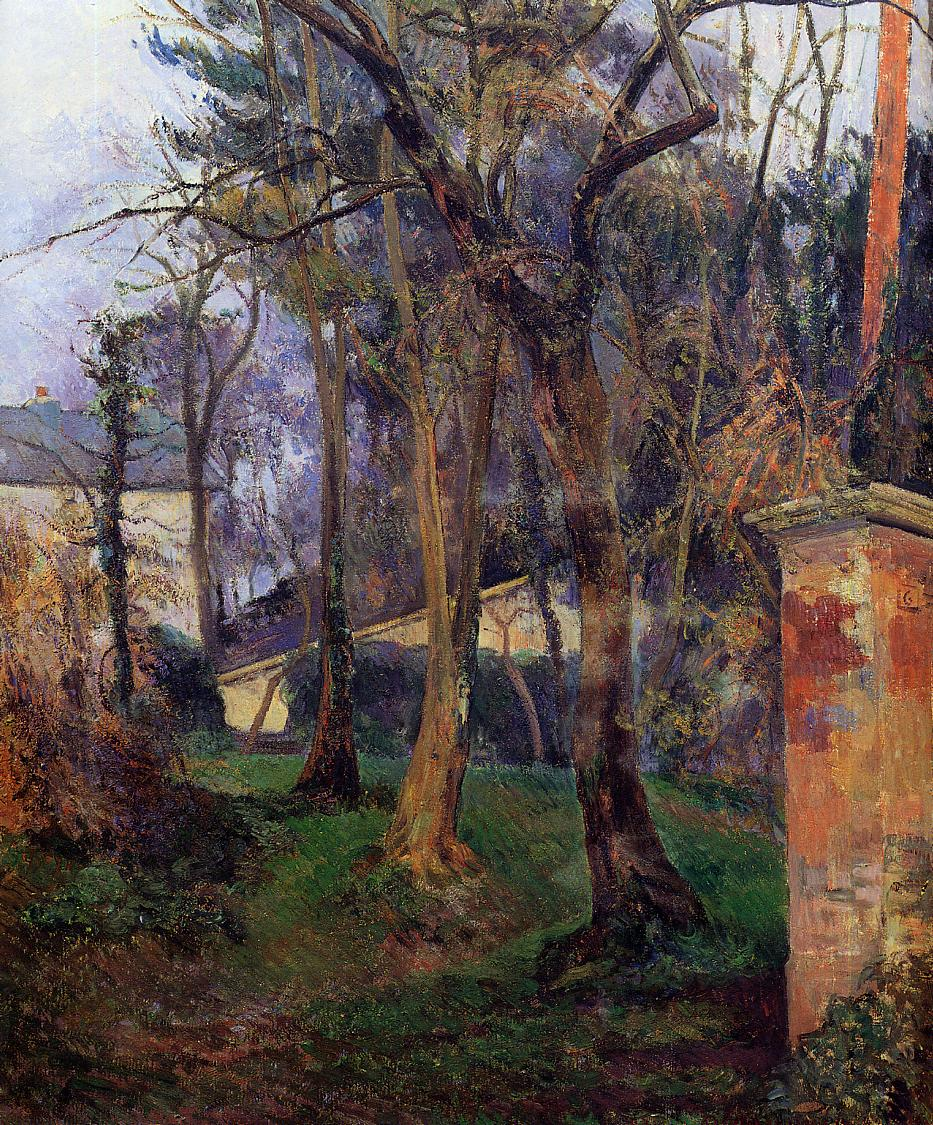Imagine this garden in a different era. How would it look during medieval times versus the present day? In medieval times, this garden might look quite different. Instead of being slightly overgrown, it could be meticulously maintained as a part of a monastic cloister or a manor's estate. Medieval gardens were often designed for both utility and beauty, featuring herbs, vegetables, and flowers arranged in geometric patterns. Paths might be lined with low hedges or interspersed with sculptures and fountains. The atmosphere would be one of serene order, a place for contemplation and retreat from the harsh realities of medieval life.

In the present day, the garden might take on a more wild and naturalistic look, reflecting modern sensibilities about letting nature take its course. There could be a mix of native and ornamental plants, with areas dedicated to attracting pollinators and creating habitats for wildlife. Modern features such as a small pond, a bench for sitting, or even a whimsical garden sculpture might be included. The current garden would exude a relaxed, casual charm, celebrating biodiversity and the beauty of untamed nature. Can you think of a modern realistic scenario involving this garden? In a modern scenario, this garden could be the beloved backyard of an artist or nature enthusiast. Every morning, the owner might enjoy a cup of tea on a rustic bench, taking in the sights and sounds of the natural surroundings. They could host small, intimate gatherings with friends or family, using the garden as a tranquil backdrop for conversations and laughter. On weekends, they might work on various gardening projects, planting seasonal flowers or adding new features like bird feeders or a small rock garden. The garden would be a private sanctuary, providing a sense of peace and connection to nature in an otherwise hectic world. 